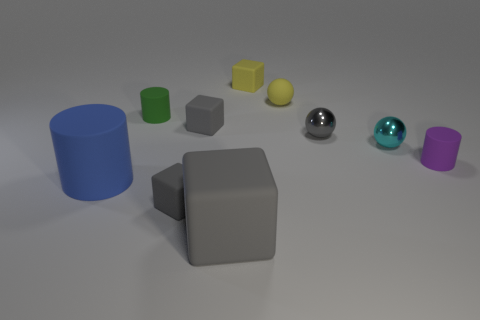Add 6 yellow balls. How many yellow balls exist? 7 Subtract all gray blocks. How many blocks are left? 1 Subtract all big matte cubes. How many cubes are left? 3 Subtract 0 yellow cylinders. How many objects are left? 10 Subtract all cylinders. How many objects are left? 7 Subtract 4 cubes. How many cubes are left? 0 Subtract all yellow spheres. Subtract all purple cylinders. How many spheres are left? 2 Subtract all green cubes. How many purple cylinders are left? 1 Subtract all blue cylinders. Subtract all tiny green rubber objects. How many objects are left? 8 Add 6 tiny gray rubber things. How many tiny gray rubber things are left? 8 